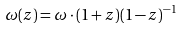<formula> <loc_0><loc_0><loc_500><loc_500>\omega ( z ) = \omega \cdot ( 1 + z ) ( 1 - z ) ^ { - 1 }</formula> 